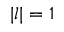<formula> <loc_0><loc_0><loc_500><loc_500>| l | = 1</formula> 